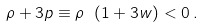Convert formula to latex. <formula><loc_0><loc_0><loc_500><loc_500>\rho + 3 p \equiv \rho \ ( 1 + 3 w ) < 0 \, .</formula> 